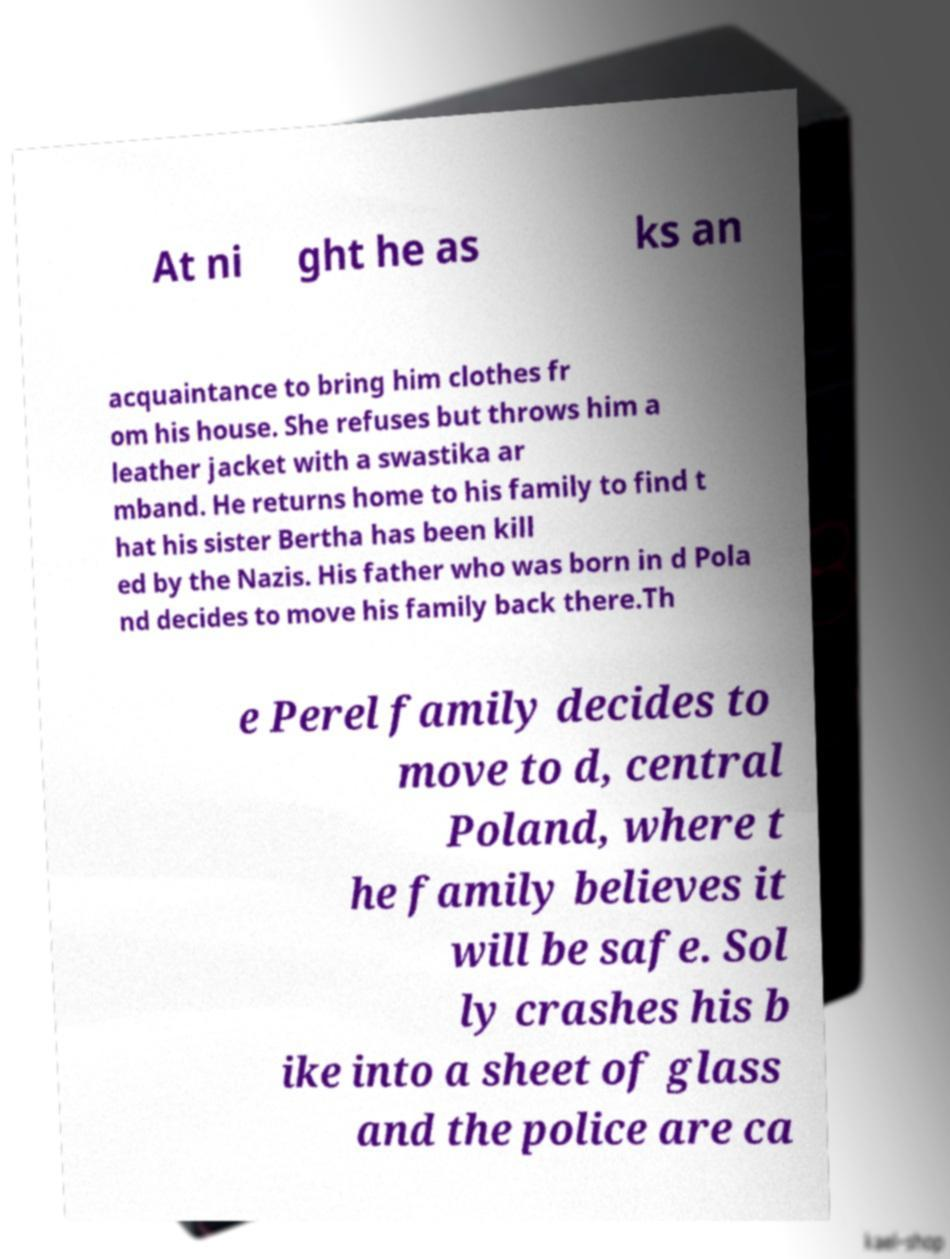Please read and relay the text visible in this image. What does it say? At ni ght he as ks an acquaintance to bring him clothes fr om his house. She refuses but throws him a leather jacket with a swastika ar mband. He returns home to his family to find t hat his sister Bertha has been kill ed by the Nazis. His father who was born in d Pola nd decides to move his family back there.Th e Perel family decides to move to d, central Poland, where t he family believes it will be safe. Sol ly crashes his b ike into a sheet of glass and the police are ca 